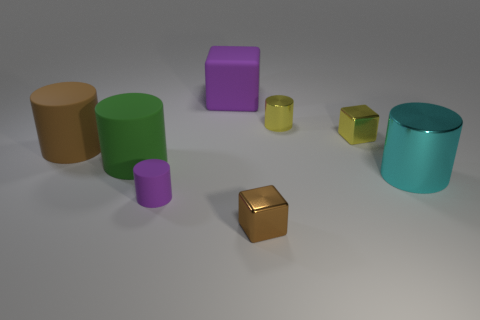There is a brown thing that is the same size as the cyan cylinder; what is its shape?
Your answer should be compact. Cylinder. Is there another tiny rubber object of the same shape as the cyan object?
Make the answer very short. Yes. Does the purple block have the same material as the object in front of the purple cylinder?
Provide a succinct answer. No. What is the color of the rubber thing that is right of the small object that is left of the metal block that is to the left of the tiny yellow metal block?
Ensure brevity in your answer.  Purple. There is a cyan cylinder that is the same size as the purple matte block; what is it made of?
Offer a terse response. Metal. What number of brown things are the same material as the big purple object?
Offer a terse response. 1. There is a shiny cylinder behind the large green cylinder; is it the same size as the cylinder on the right side of the yellow shiny cylinder?
Offer a terse response. No. What is the color of the cube that is on the right side of the small brown thing?
Ensure brevity in your answer.  Yellow. There is a tiny block that is the same color as the tiny metallic cylinder; what is it made of?
Your answer should be very brief. Metal. What number of big cubes are the same color as the tiny matte object?
Offer a very short reply. 1. 